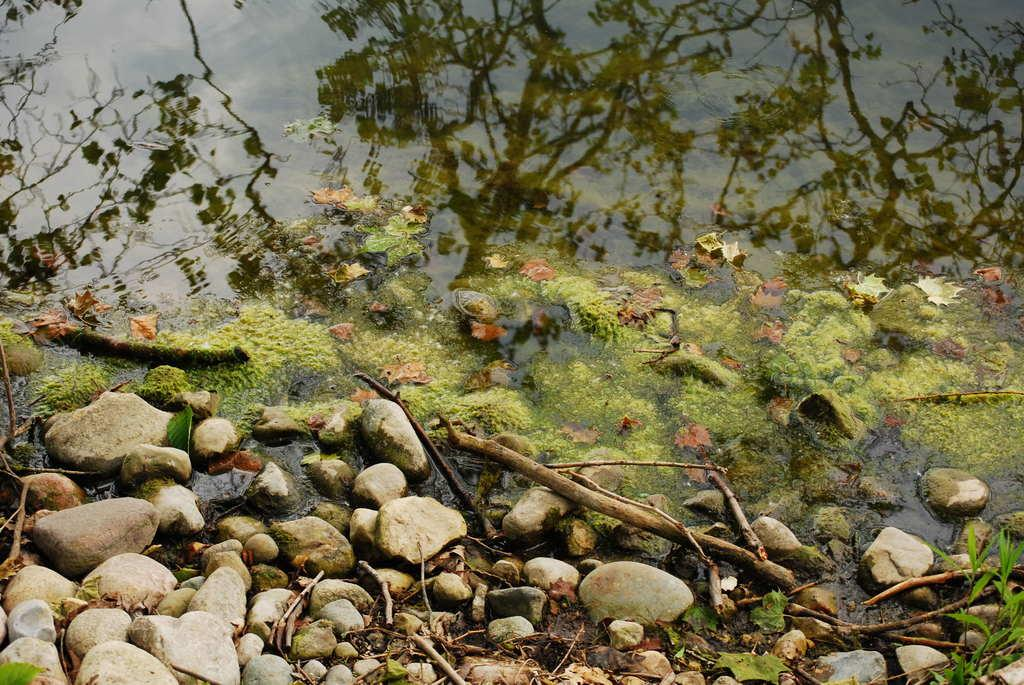What type of natural elements can be seen in the image? There are rocks and water visible in the image. What objects are made of wood in the image? There are wooden sticks in the image. What is floating on the water in the image? Dry leaves and algae are present on the water. How does the goose use the pump in the image? There is no goose or pump present in the image. 